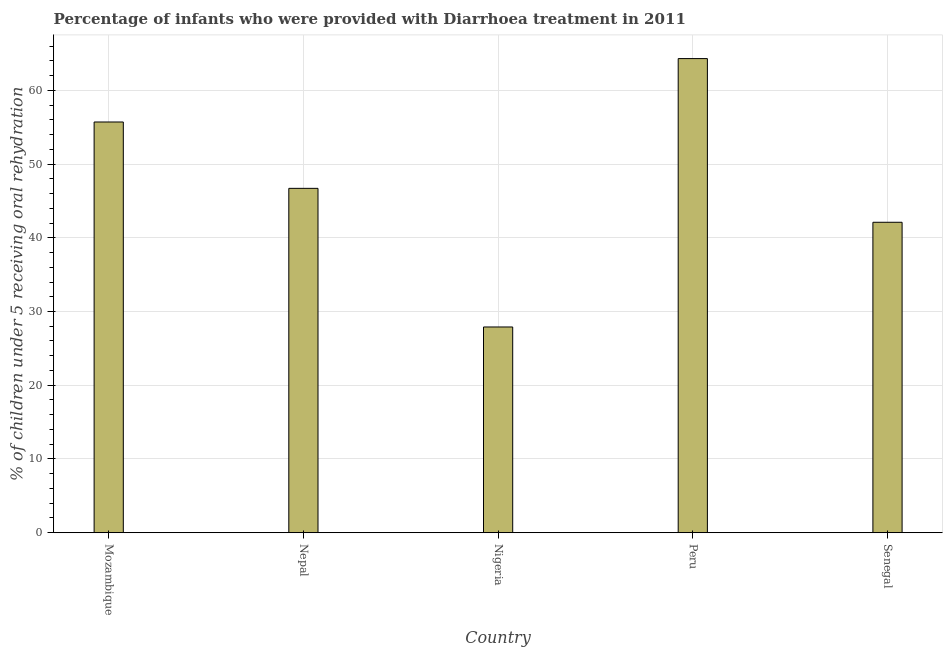Does the graph contain grids?
Offer a very short reply. Yes. What is the title of the graph?
Your answer should be compact. Percentage of infants who were provided with Diarrhoea treatment in 2011. What is the label or title of the Y-axis?
Provide a succinct answer. % of children under 5 receiving oral rehydration. What is the percentage of children who were provided with treatment diarrhoea in Nepal?
Your answer should be compact. 46.7. Across all countries, what is the maximum percentage of children who were provided with treatment diarrhoea?
Offer a very short reply. 64.3. Across all countries, what is the minimum percentage of children who were provided with treatment diarrhoea?
Your answer should be compact. 27.9. In which country was the percentage of children who were provided with treatment diarrhoea minimum?
Give a very brief answer. Nigeria. What is the sum of the percentage of children who were provided with treatment diarrhoea?
Your response must be concise. 236.7. What is the difference between the percentage of children who were provided with treatment diarrhoea in Nepal and Peru?
Offer a very short reply. -17.6. What is the average percentage of children who were provided with treatment diarrhoea per country?
Ensure brevity in your answer.  47.34. What is the median percentage of children who were provided with treatment diarrhoea?
Make the answer very short. 46.7. What is the ratio of the percentage of children who were provided with treatment diarrhoea in Mozambique to that in Peru?
Keep it short and to the point. 0.87. Is the percentage of children who were provided with treatment diarrhoea in Mozambique less than that in Senegal?
Make the answer very short. No. Is the sum of the percentage of children who were provided with treatment diarrhoea in Nigeria and Senegal greater than the maximum percentage of children who were provided with treatment diarrhoea across all countries?
Keep it short and to the point. Yes. What is the difference between the highest and the lowest percentage of children who were provided with treatment diarrhoea?
Keep it short and to the point. 36.4. In how many countries, is the percentage of children who were provided with treatment diarrhoea greater than the average percentage of children who were provided with treatment diarrhoea taken over all countries?
Ensure brevity in your answer.  2. What is the % of children under 5 receiving oral rehydration of Mozambique?
Offer a very short reply. 55.7. What is the % of children under 5 receiving oral rehydration of Nepal?
Your response must be concise. 46.7. What is the % of children under 5 receiving oral rehydration in Nigeria?
Ensure brevity in your answer.  27.9. What is the % of children under 5 receiving oral rehydration in Peru?
Your response must be concise. 64.3. What is the % of children under 5 receiving oral rehydration of Senegal?
Offer a very short reply. 42.1. What is the difference between the % of children under 5 receiving oral rehydration in Mozambique and Nepal?
Make the answer very short. 9. What is the difference between the % of children under 5 receiving oral rehydration in Mozambique and Nigeria?
Your response must be concise. 27.8. What is the difference between the % of children under 5 receiving oral rehydration in Mozambique and Senegal?
Provide a succinct answer. 13.6. What is the difference between the % of children under 5 receiving oral rehydration in Nepal and Peru?
Your response must be concise. -17.6. What is the difference between the % of children under 5 receiving oral rehydration in Nepal and Senegal?
Make the answer very short. 4.6. What is the difference between the % of children under 5 receiving oral rehydration in Nigeria and Peru?
Ensure brevity in your answer.  -36.4. What is the ratio of the % of children under 5 receiving oral rehydration in Mozambique to that in Nepal?
Offer a terse response. 1.19. What is the ratio of the % of children under 5 receiving oral rehydration in Mozambique to that in Nigeria?
Offer a terse response. 2. What is the ratio of the % of children under 5 receiving oral rehydration in Mozambique to that in Peru?
Provide a short and direct response. 0.87. What is the ratio of the % of children under 5 receiving oral rehydration in Mozambique to that in Senegal?
Give a very brief answer. 1.32. What is the ratio of the % of children under 5 receiving oral rehydration in Nepal to that in Nigeria?
Offer a terse response. 1.67. What is the ratio of the % of children under 5 receiving oral rehydration in Nepal to that in Peru?
Offer a terse response. 0.73. What is the ratio of the % of children under 5 receiving oral rehydration in Nepal to that in Senegal?
Ensure brevity in your answer.  1.11. What is the ratio of the % of children under 5 receiving oral rehydration in Nigeria to that in Peru?
Provide a short and direct response. 0.43. What is the ratio of the % of children under 5 receiving oral rehydration in Nigeria to that in Senegal?
Provide a short and direct response. 0.66. What is the ratio of the % of children under 5 receiving oral rehydration in Peru to that in Senegal?
Provide a short and direct response. 1.53. 